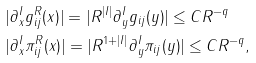Convert formula to latex. <formula><loc_0><loc_0><loc_500><loc_500>& | \partial ^ { I } _ { x } g _ { i j } ^ { R } ( x ) | = | R ^ { | I | } \partial ^ { I } _ { y } g _ { i j } ( y ) | \leq C R ^ { - q } \\ & | \partial ^ { I } _ { x } \pi ^ { R } _ { i j } ( x ) | = | R ^ { 1 + | I | } \partial ^ { I } _ { y } \pi _ { i j } ( y ) | \leq C R ^ { - q } ,</formula> 